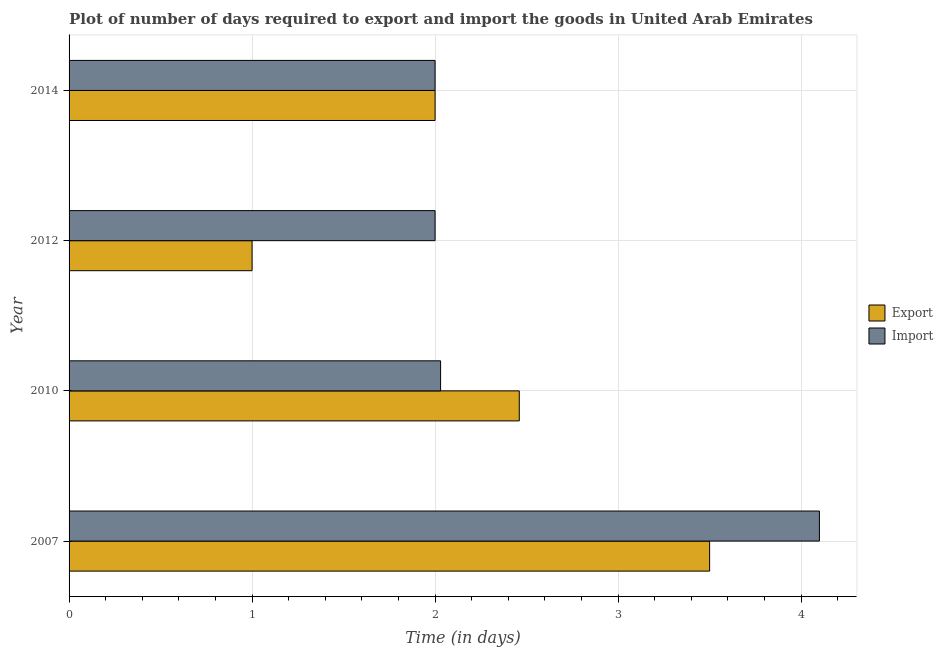How many groups of bars are there?
Provide a short and direct response. 4. Are the number of bars per tick equal to the number of legend labels?
Offer a very short reply. Yes. Are the number of bars on each tick of the Y-axis equal?
Your answer should be compact. Yes. How many bars are there on the 2nd tick from the bottom?
Make the answer very short. 2. What is the label of the 2nd group of bars from the top?
Ensure brevity in your answer.  2012. In how many cases, is the number of bars for a given year not equal to the number of legend labels?
Offer a very short reply. 0. Across all years, what is the maximum time required to export?
Make the answer very short. 3.5. Across all years, what is the minimum time required to import?
Offer a terse response. 2. In which year was the time required to export maximum?
Your response must be concise. 2007. In which year was the time required to export minimum?
Your answer should be very brief. 2012. What is the total time required to export in the graph?
Make the answer very short. 8.96. What is the difference between the time required to import in 2007 and the time required to export in 2012?
Provide a short and direct response. 3.1. What is the average time required to export per year?
Ensure brevity in your answer.  2.24. Is the difference between the time required to export in 2012 and 2014 greater than the difference between the time required to import in 2012 and 2014?
Make the answer very short. No. What is the difference between the highest and the second highest time required to export?
Provide a succinct answer. 1.04. What is the difference between the highest and the lowest time required to import?
Make the answer very short. 2.1. In how many years, is the time required to export greater than the average time required to export taken over all years?
Offer a terse response. 2. What does the 1st bar from the top in 2014 represents?
Provide a short and direct response. Import. What does the 2nd bar from the bottom in 2014 represents?
Provide a succinct answer. Import. How many years are there in the graph?
Offer a very short reply. 4. Are the values on the major ticks of X-axis written in scientific E-notation?
Your answer should be very brief. No. Does the graph contain grids?
Ensure brevity in your answer.  Yes. How many legend labels are there?
Keep it short and to the point. 2. How are the legend labels stacked?
Give a very brief answer. Vertical. What is the title of the graph?
Your answer should be very brief. Plot of number of days required to export and import the goods in United Arab Emirates. Does "DAC donors" appear as one of the legend labels in the graph?
Offer a very short reply. No. What is the label or title of the X-axis?
Offer a very short reply. Time (in days). What is the label or title of the Y-axis?
Give a very brief answer. Year. What is the Time (in days) of Export in 2010?
Keep it short and to the point. 2.46. What is the Time (in days) in Import in 2010?
Keep it short and to the point. 2.03. What is the Time (in days) in Export in 2012?
Ensure brevity in your answer.  1. Across all years, what is the minimum Time (in days) in Import?
Give a very brief answer. 2. What is the total Time (in days) of Export in the graph?
Offer a terse response. 8.96. What is the total Time (in days) in Import in the graph?
Make the answer very short. 10.13. What is the difference between the Time (in days) in Import in 2007 and that in 2010?
Provide a succinct answer. 2.07. What is the difference between the Time (in days) of Export in 2007 and that in 2012?
Keep it short and to the point. 2.5. What is the difference between the Time (in days) in Export in 2007 and that in 2014?
Provide a succinct answer. 1.5. What is the difference between the Time (in days) of Export in 2010 and that in 2012?
Ensure brevity in your answer.  1.46. What is the difference between the Time (in days) in Import in 2010 and that in 2012?
Provide a short and direct response. 0.03. What is the difference between the Time (in days) in Export in 2010 and that in 2014?
Your response must be concise. 0.46. What is the difference between the Time (in days) in Import in 2010 and that in 2014?
Keep it short and to the point. 0.03. What is the difference between the Time (in days) of Import in 2012 and that in 2014?
Your answer should be very brief. 0. What is the difference between the Time (in days) of Export in 2007 and the Time (in days) of Import in 2010?
Give a very brief answer. 1.47. What is the difference between the Time (in days) in Export in 2007 and the Time (in days) in Import in 2012?
Give a very brief answer. 1.5. What is the difference between the Time (in days) of Export in 2010 and the Time (in days) of Import in 2012?
Keep it short and to the point. 0.46. What is the difference between the Time (in days) in Export in 2010 and the Time (in days) in Import in 2014?
Make the answer very short. 0.46. What is the average Time (in days) in Export per year?
Your response must be concise. 2.24. What is the average Time (in days) of Import per year?
Provide a short and direct response. 2.53. In the year 2010, what is the difference between the Time (in days) of Export and Time (in days) of Import?
Offer a terse response. 0.43. What is the ratio of the Time (in days) of Export in 2007 to that in 2010?
Offer a terse response. 1.42. What is the ratio of the Time (in days) of Import in 2007 to that in 2010?
Make the answer very short. 2.02. What is the ratio of the Time (in days) of Import in 2007 to that in 2012?
Offer a very short reply. 2.05. What is the ratio of the Time (in days) of Import in 2007 to that in 2014?
Offer a very short reply. 2.05. What is the ratio of the Time (in days) of Export in 2010 to that in 2012?
Provide a succinct answer. 2.46. What is the ratio of the Time (in days) in Import in 2010 to that in 2012?
Make the answer very short. 1.01. What is the ratio of the Time (in days) in Export in 2010 to that in 2014?
Offer a very short reply. 1.23. What is the ratio of the Time (in days) in Import in 2010 to that in 2014?
Ensure brevity in your answer.  1.01. What is the ratio of the Time (in days) of Export in 2012 to that in 2014?
Keep it short and to the point. 0.5. What is the ratio of the Time (in days) in Import in 2012 to that in 2014?
Provide a short and direct response. 1. What is the difference between the highest and the second highest Time (in days) of Import?
Offer a very short reply. 2.07. 